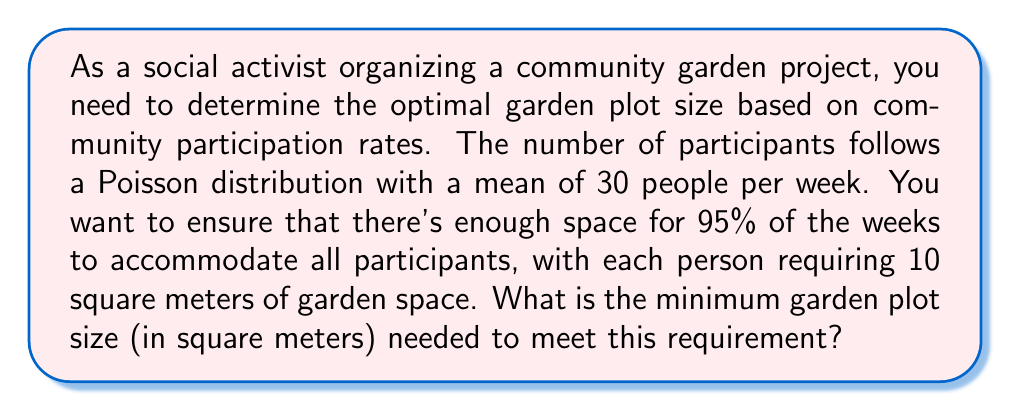What is the answer to this math problem? Let's approach this step-by-step:

1) The number of participants follows a Poisson distribution with mean $\lambda = 30$.

2) We need to find the number of participants that will cover 95% of the weeks. This is equivalent to finding the 95th percentile of the Poisson distribution.

3) For a Poisson distribution with large $\lambda$ (generally $\lambda > 10$), we can approximate it with a normal distribution:

   $N(\mu = \lambda, \sigma = \sqrt{\lambda})$

4) In this case, $\mu = 30$ and $\sigma = \sqrt{30} \approx 5.477$

5) The 95th percentile of a normal distribution is approximately 1.645 standard deviations above the mean:

   $X_{95} = \mu + 1.645\sigma = 30 + 1.645 * 5.477 \approx 39.01$

6) Rounding up to the nearest whole number (as we can't have a fractional number of people), we get 40 people.

7) Each person requires 10 square meters, so the total area needed is:

   $\text{Area} = 40 * 10 = 400$ square meters

Therefore, the minimum garden plot size needed is 400 square meters.
Answer: 400 square meters 